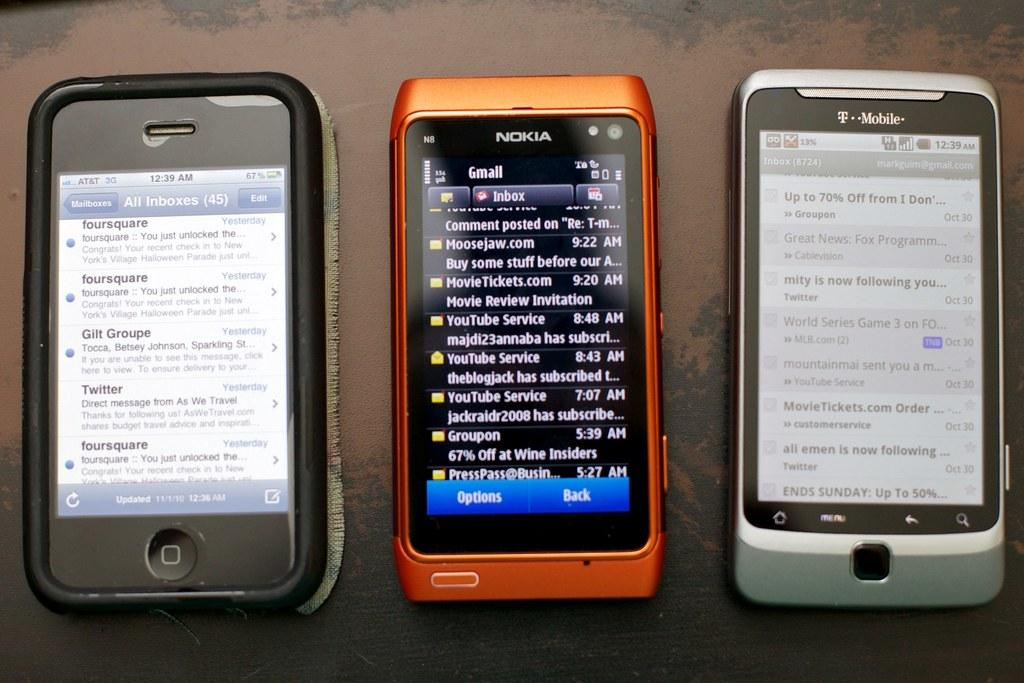<image>
Provide a brief description of the given image. Three phones are resting side by side, including a Nokia phone in the middle. 